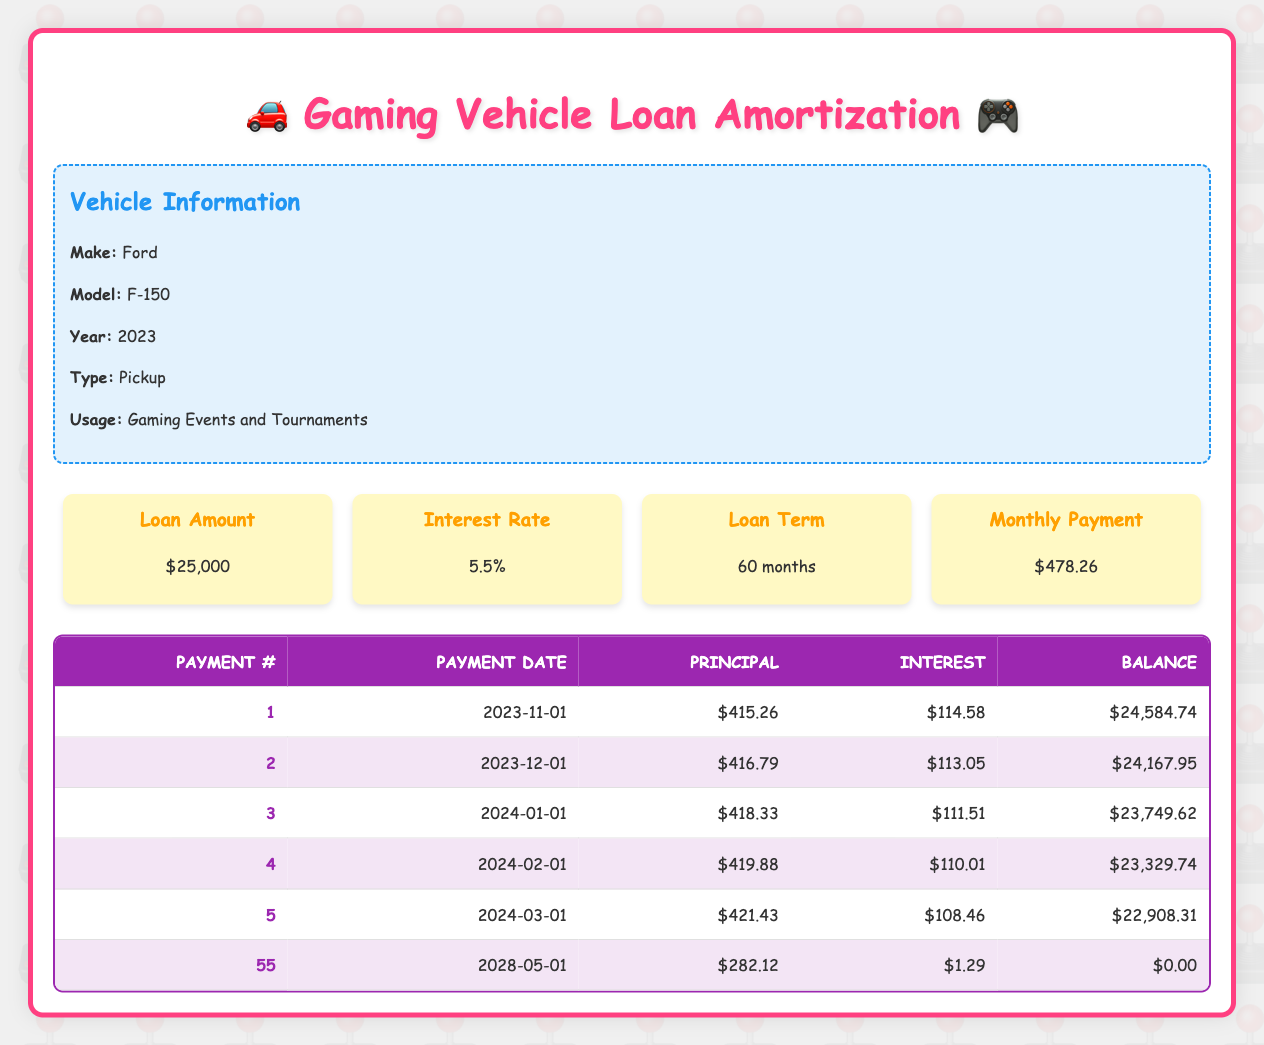What is the monthly payment for the car loan? The monthly payment is listed directly in the loan details section of the table, which states $478.26.
Answer: $478.26 How much will be paid toward the principal on the 5th payment? The payment schedule shows that the principal payment for the 5th payment is $421.43, found in the respective row of the table.
Answer: $421.43 What is the total interest paid in the first three payments? To find the total interest paid, add the interest payments for the first three rows. The interest payments are $114.58 (1st), $113.05 (2nd), and $111.51 (3rd). So, the total is 114.58 + 113.05 + 111.51 = 339.14.
Answer: $339.14 Is the remaining balance after the 10th payment greater than $20,000? The remaining balance after the 10th payment is $20,777.64, which is greater than $20,000. So, the answer is yes.
Answer: Yes What is the average principal payment over the first six payments? The principal payments for the first six installments are $415.26, $416.79, $418.33, $419.88, $421.43, and $423.00. Adding these gives 415.26 + 416.79 + 418.33 + 419.88 + 421.43 + 423.00 = 2,414.69. There are 6 payments, so the average is 2414.69 / 6 = 402.45.
Answer: $402.45 How much interest is paid on the last payment? The interest payment listed for the last payment (55th payment) is $1.29, which is shown directly in the table.
Answer: $1.29 What is the remaining balance after the 25th payment? The table indicates that the remaining balance after the 25th payment is $14,157.59, found in the corresponding row of the payment schedule.
Answer: $14,157.59 Does the interest payment decrease over time? Yes, as seen from the table, interest payments decrease with each payment due to the amortization process. For example, it starts at $114.58 for the first payment and ends at $1.29 for the last payment, confirming the decrease.
Answer: Yes What is the total principal paid by the end of the loan? The total principal paid by the end of the loan is the original loan amount of $25,000, as all of it is paid off over the 55 payments.
Answer: $25,000 